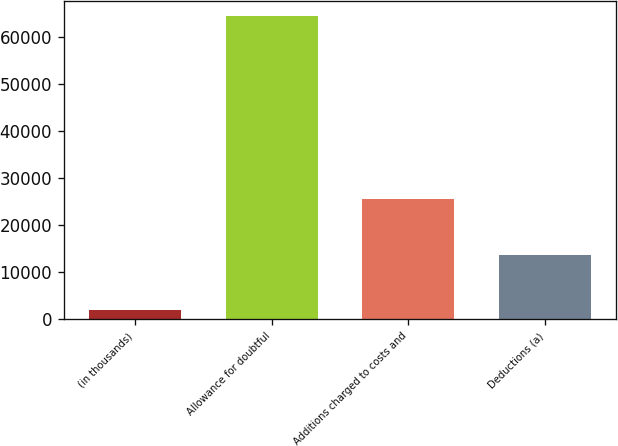Convert chart to OTSL. <chart><loc_0><loc_0><loc_500><loc_500><bar_chart><fcel>(in thousands)<fcel>Allowance for doubtful<fcel>Additions charged to costs and<fcel>Deductions (a)<nl><fcel>2018<fcel>64561<fcel>25529<fcel>13754<nl></chart> 